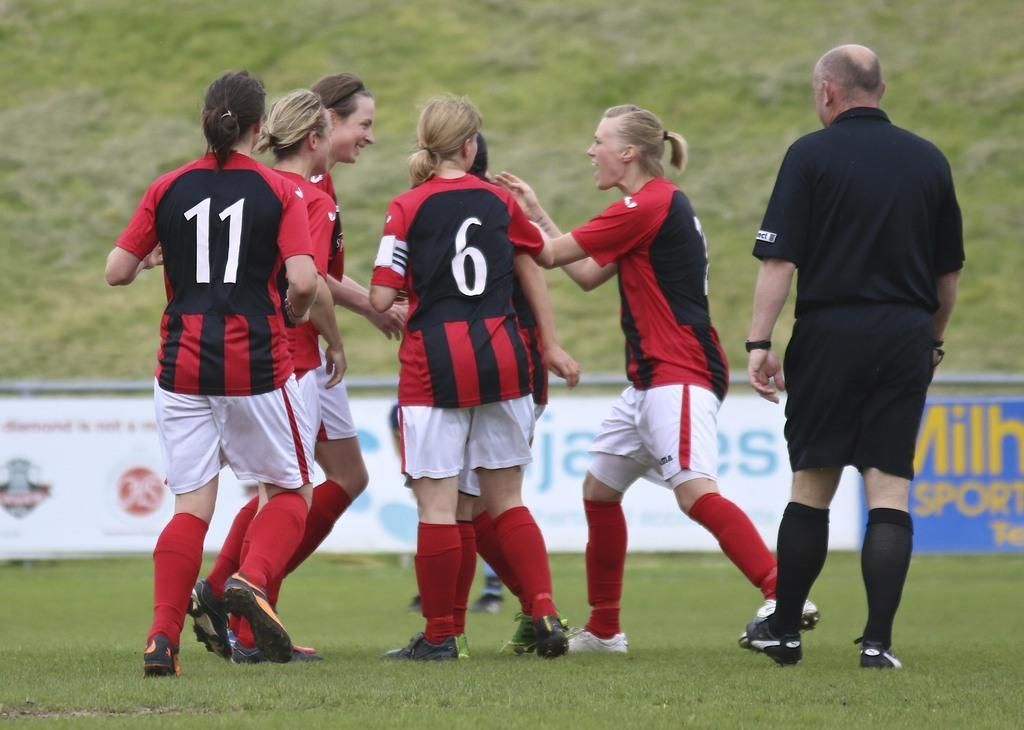<image>
Write a terse but informative summary of the picture. A female athlete wearing the number 11 on the back of her jersey huddles with her teammates. 